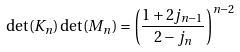<formula> <loc_0><loc_0><loc_500><loc_500>\det ( K _ { n } ) \det ( M _ { n } ) = \left ( \frac { 1 + 2 j _ { n - 1 } } { 2 - j _ { n } } \right ) ^ { n - 2 }</formula> 